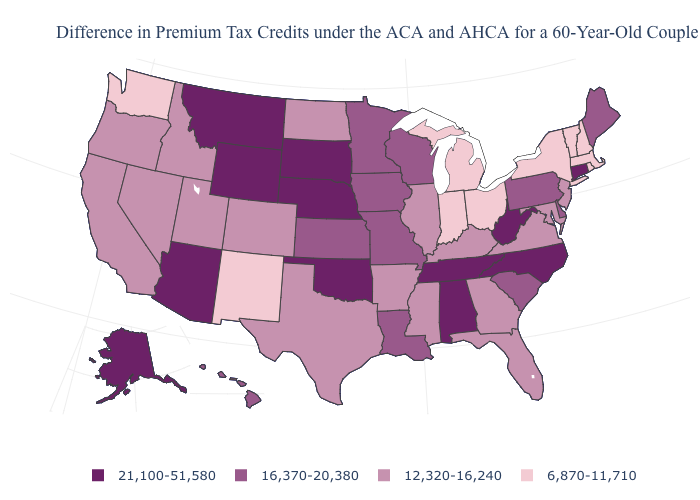Does New Hampshire have the lowest value in the USA?
Keep it brief. Yes. Name the states that have a value in the range 6,870-11,710?
Answer briefly. Indiana, Massachusetts, Michigan, New Hampshire, New Mexico, New York, Ohio, Rhode Island, Vermont, Washington. What is the value of Washington?
Short answer required. 6,870-11,710. What is the lowest value in states that border Ohio?
Answer briefly. 6,870-11,710. Name the states that have a value in the range 12,320-16,240?
Quick response, please. Arkansas, California, Colorado, Florida, Georgia, Idaho, Illinois, Kentucky, Maryland, Mississippi, Nevada, New Jersey, North Dakota, Oregon, Texas, Utah, Virginia. What is the value of Idaho?
Write a very short answer. 12,320-16,240. What is the value of Oklahoma?
Concise answer only. 21,100-51,580. Is the legend a continuous bar?
Quick response, please. No. What is the value of Delaware?
Be succinct. 16,370-20,380. Among the states that border Massachusetts , does Connecticut have the lowest value?
Quick response, please. No. Name the states that have a value in the range 12,320-16,240?
Short answer required. Arkansas, California, Colorado, Florida, Georgia, Idaho, Illinois, Kentucky, Maryland, Mississippi, Nevada, New Jersey, North Dakota, Oregon, Texas, Utah, Virginia. Does West Virginia have the same value as Wisconsin?
Answer briefly. No. Does South Dakota have the highest value in the MidWest?
Concise answer only. Yes. How many symbols are there in the legend?
Concise answer only. 4. Name the states that have a value in the range 12,320-16,240?
Give a very brief answer. Arkansas, California, Colorado, Florida, Georgia, Idaho, Illinois, Kentucky, Maryland, Mississippi, Nevada, New Jersey, North Dakota, Oregon, Texas, Utah, Virginia. 